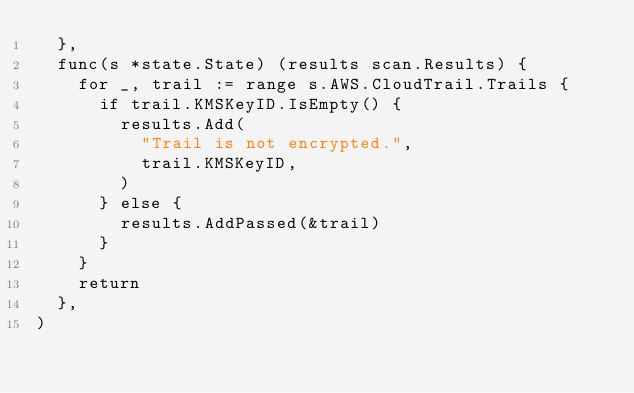<code> <loc_0><loc_0><loc_500><loc_500><_Go_>	},
	func(s *state.State) (results scan.Results) {
		for _, trail := range s.AWS.CloudTrail.Trails {
			if trail.KMSKeyID.IsEmpty() {
				results.Add(
					"Trail is not encrypted.",
					trail.KMSKeyID,
				)
			} else {
				results.AddPassed(&trail)
			}
		}
		return
	},
)
</code> 